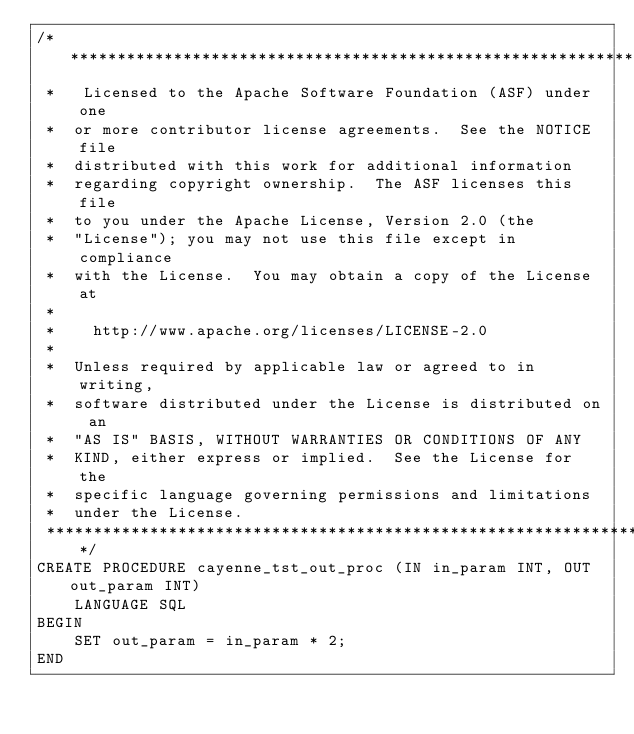Convert code to text. <code><loc_0><loc_0><loc_500><loc_500><_SQL_>/*****************************************************************
 *   Licensed to the Apache Software Foundation (ASF) under one
 *  or more contributor license agreements.  See the NOTICE file
 *  distributed with this work for additional information
 *  regarding copyright ownership.  The ASF licenses this file
 *  to you under the Apache License, Version 2.0 (the
 *  "License"); you may not use this file except in compliance
 *  with the License.  You may obtain a copy of the License at
 *
 *    http://www.apache.org/licenses/LICENSE-2.0
 *
 *  Unless required by applicable law or agreed to in writing,
 *  software distributed under the License is distributed on an
 *  "AS IS" BASIS, WITHOUT WARRANTIES OR CONDITIONS OF ANY
 *  KIND, either express or implied.  See the License for the
 *  specific language governing permissions and limitations
 *  under the License.
 ****************************************************************/
CREATE PROCEDURE cayenne_tst_out_proc (IN in_param INT, OUT out_param INT) 
	LANGUAGE SQL
BEGIN 
	SET out_param = in_param * 2;
END</code> 